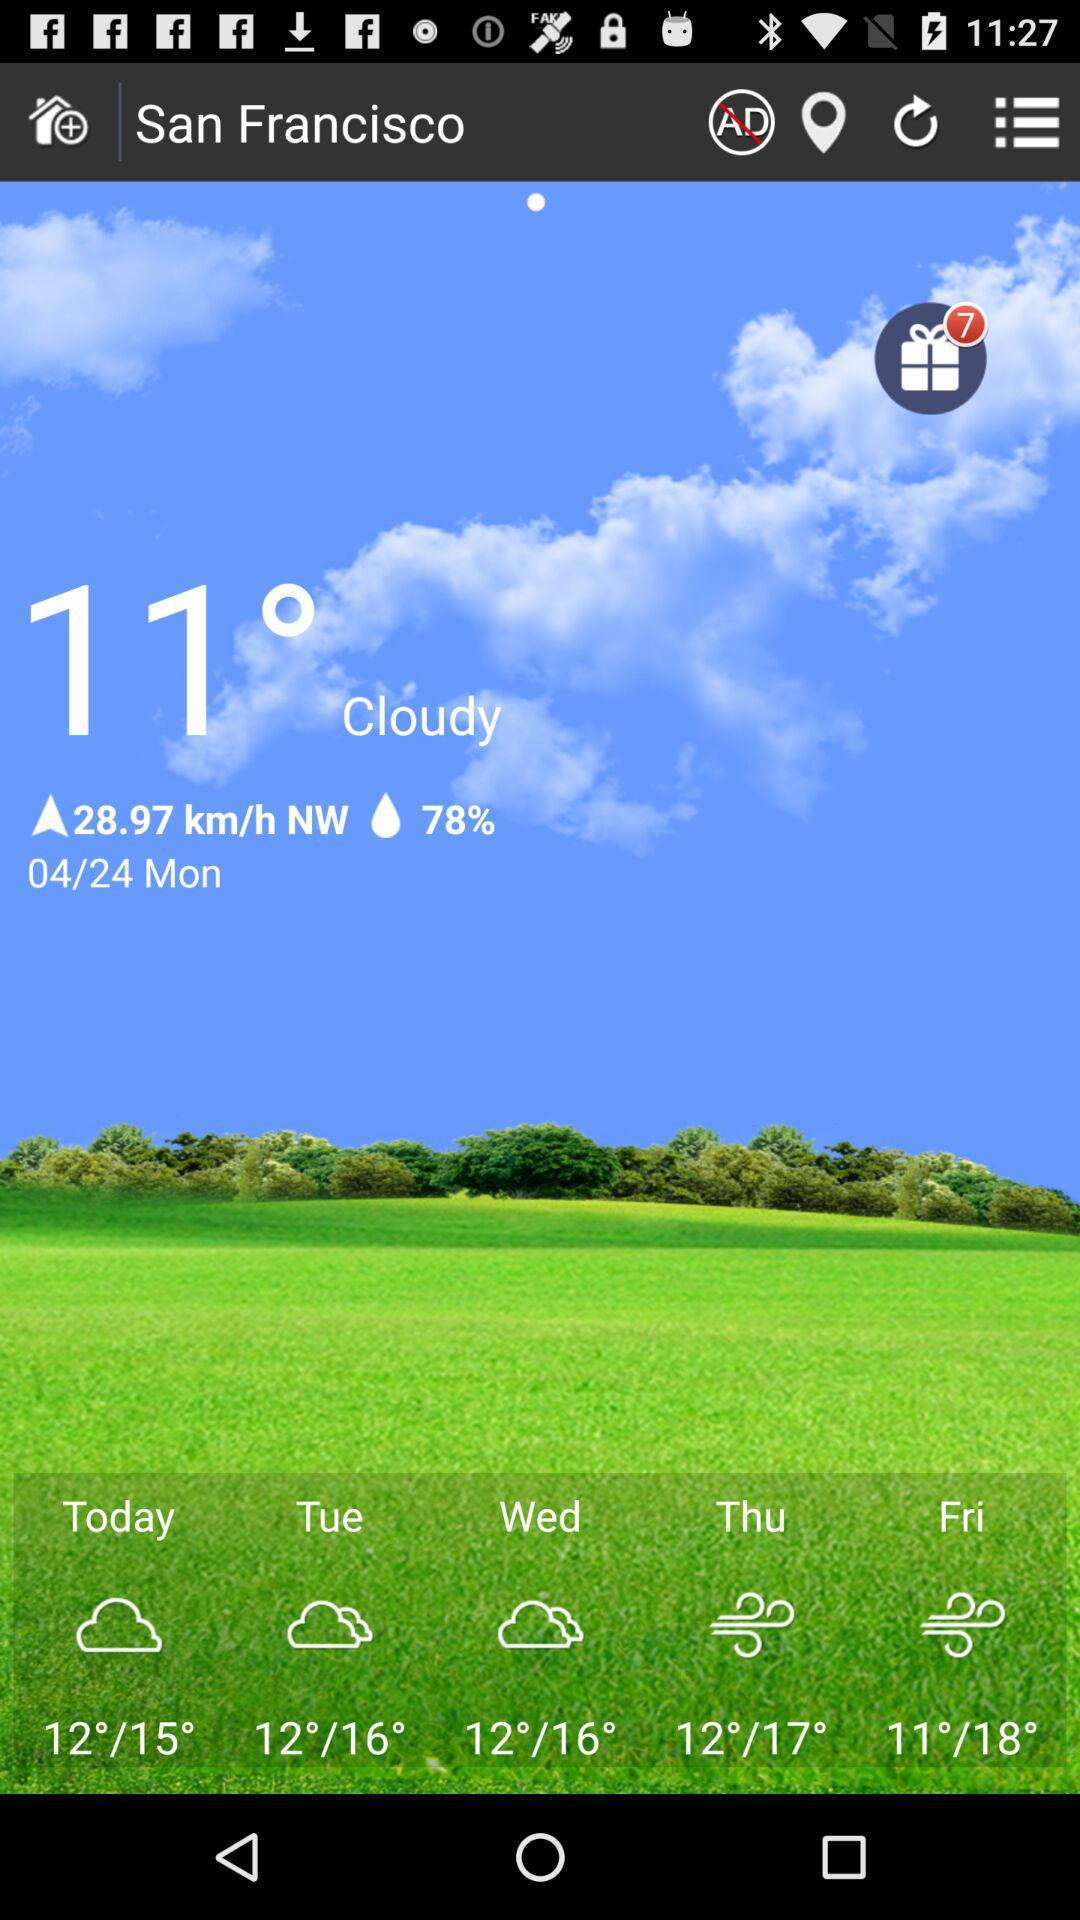How many gifts are there? There are 7 gifts. 